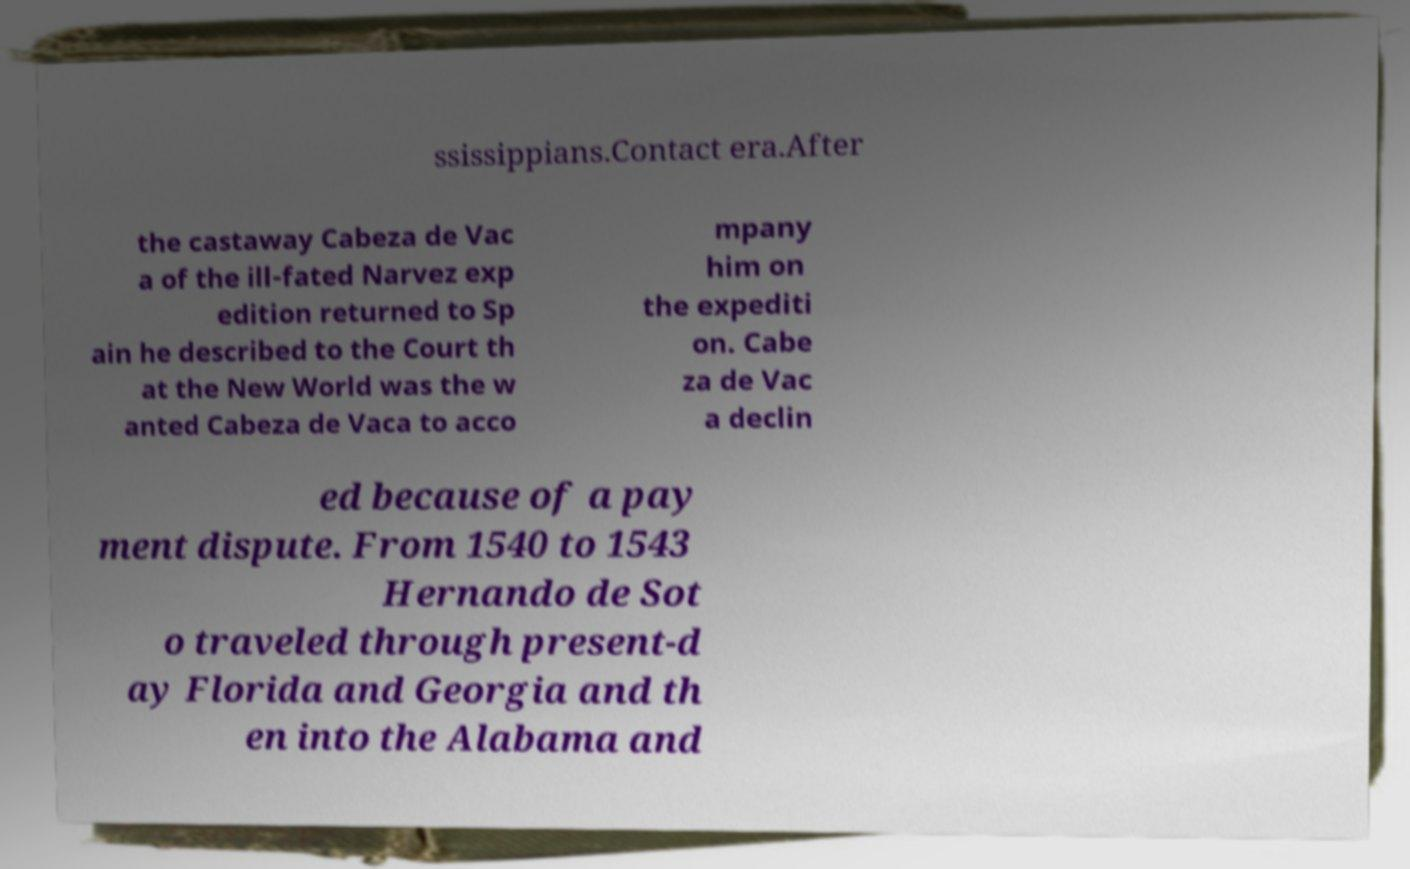For documentation purposes, I need the text within this image transcribed. Could you provide that? ssissippians.Contact era.After the castaway Cabeza de Vac a of the ill-fated Narvez exp edition returned to Sp ain he described to the Court th at the New World was the w anted Cabeza de Vaca to acco mpany him on the expediti on. Cabe za de Vac a declin ed because of a pay ment dispute. From 1540 to 1543 Hernando de Sot o traveled through present-d ay Florida and Georgia and th en into the Alabama and 